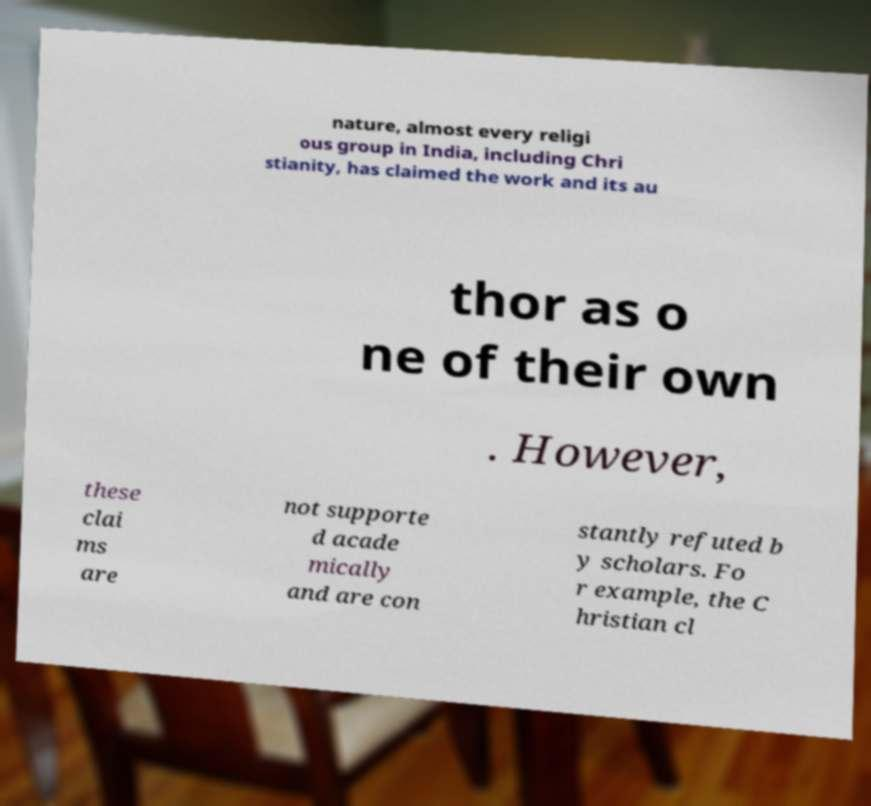Could you extract and type out the text from this image? nature, almost every religi ous group in India, including Chri stianity, has claimed the work and its au thor as o ne of their own . However, these clai ms are not supporte d acade mically and are con stantly refuted b y scholars. Fo r example, the C hristian cl 